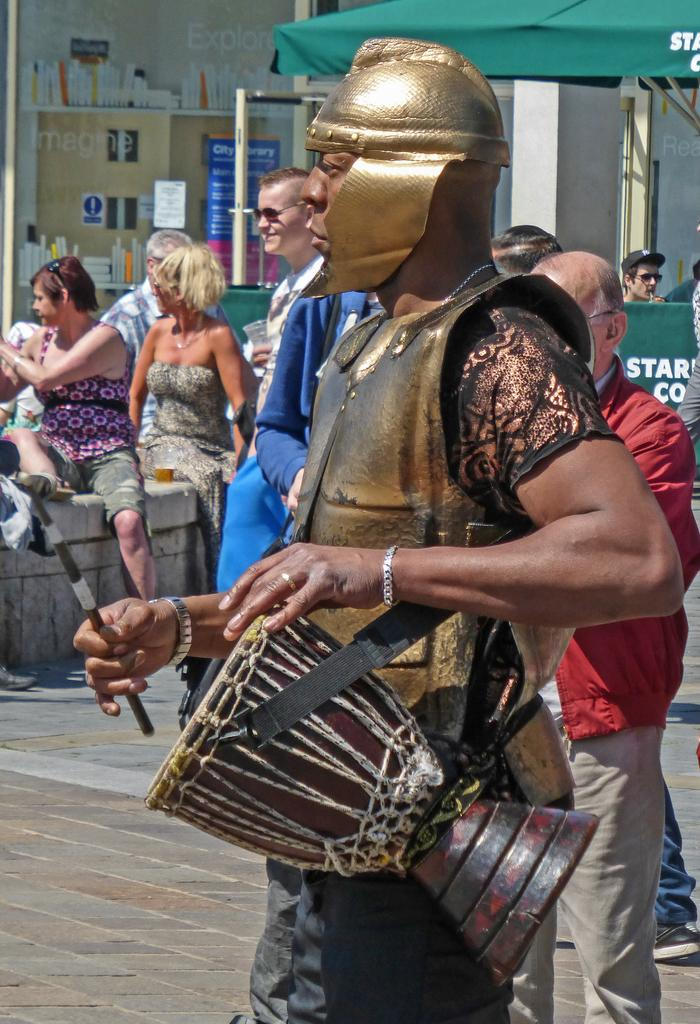What is the man in the image doing? The man is standing and playing the drum. What is the man wearing in the image? The man is wearing a gold color dress. What are the women in the image doing? The women are sitting on a wall in the image. What is happening on the road in the image? There are people walking on the road in the image. What type of store can be seen in the image? There is no store present in the image. How does the man's digestion affect his drum playing in the image? There is no information about the man's digestion in the image, and it does not affect his drum playing. 